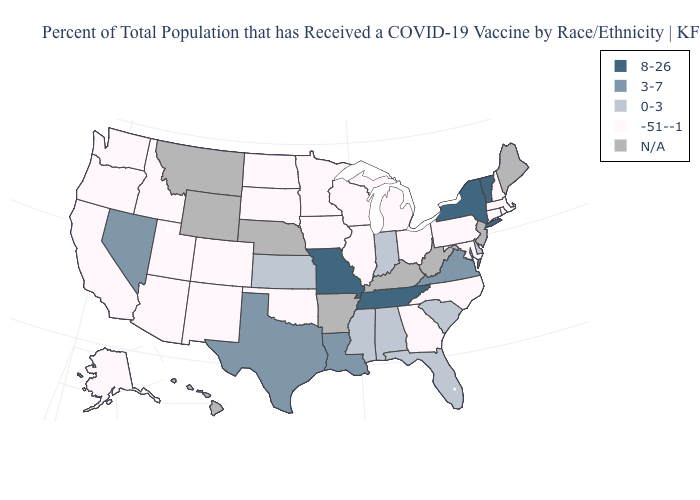What is the value of New Hampshire?
Concise answer only. -51--1. Does the map have missing data?
Give a very brief answer. Yes. Does the map have missing data?
Quick response, please. Yes. Does Tennessee have the highest value in the USA?
Write a very short answer. Yes. Name the states that have a value in the range -51--1?
Concise answer only. Alaska, Arizona, California, Colorado, Connecticut, Georgia, Idaho, Illinois, Iowa, Maryland, Massachusetts, Michigan, Minnesota, New Hampshire, New Mexico, North Carolina, North Dakota, Ohio, Oklahoma, Oregon, Pennsylvania, Rhode Island, South Dakota, Utah, Washington, Wisconsin. Among the states that border Wisconsin , which have the highest value?
Answer briefly. Illinois, Iowa, Michigan, Minnesota. What is the value of New Hampshire?
Keep it brief. -51--1. What is the lowest value in states that border Wyoming?
Keep it brief. -51--1. Name the states that have a value in the range N/A?
Answer briefly. Arkansas, Hawaii, Kentucky, Maine, Montana, Nebraska, New Jersey, West Virginia, Wyoming. What is the value of New Hampshire?
Give a very brief answer. -51--1. Which states have the highest value in the USA?
Be succinct. Missouri, New York, Tennessee, Vermont. How many symbols are there in the legend?
Be succinct. 5. Does Missouri have the highest value in the USA?
Short answer required. Yes. 